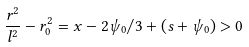Convert formula to latex. <formula><loc_0><loc_0><loc_500><loc_500>\frac { r ^ { 2 } } { l ^ { 2 } } - r _ { 0 } ^ { 2 } = x - 2 \psi _ { 0 } / 3 + ( s + \psi _ { 0 } ) > 0</formula> 